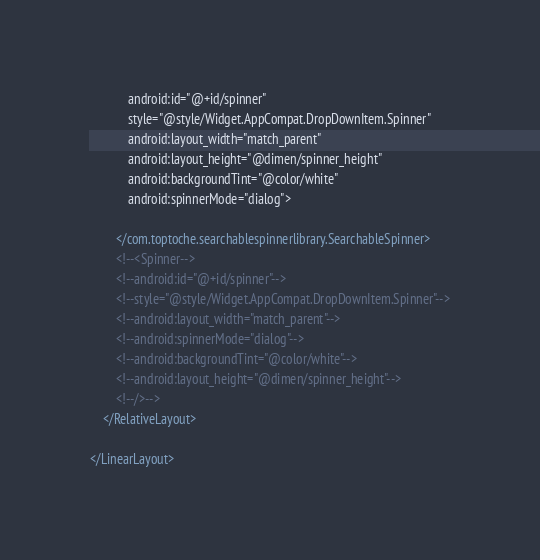<code> <loc_0><loc_0><loc_500><loc_500><_XML_>            android:id="@+id/spinner"
            style="@style/Widget.AppCompat.DropDownItem.Spinner"
            android:layout_width="match_parent"
            android:layout_height="@dimen/spinner_height"
            android:backgroundTint="@color/white"
            android:spinnerMode="dialog">

        </com.toptoche.searchablespinnerlibrary.SearchableSpinner>
        <!--<Spinner-->
        <!--android:id="@+id/spinner"-->
        <!--style="@style/Widget.AppCompat.DropDownItem.Spinner"-->
        <!--android:layout_width="match_parent"-->
        <!--android:spinnerMode="dialog"-->
        <!--android:backgroundTint="@color/white"-->
        <!--android:layout_height="@dimen/spinner_height"-->
        <!--/>-->
    </RelativeLayout>

</LinearLayout></code> 